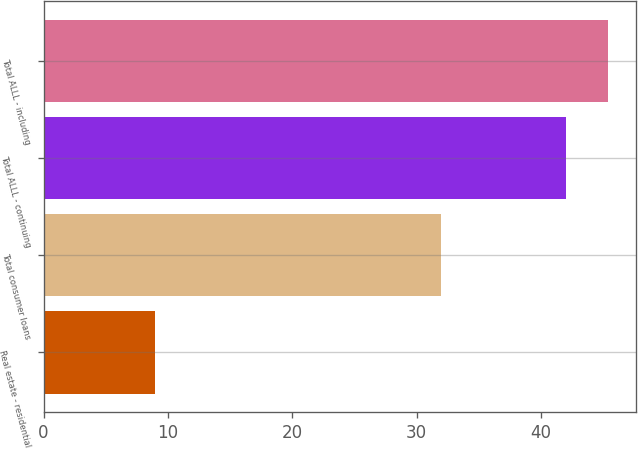<chart> <loc_0><loc_0><loc_500><loc_500><bar_chart><fcel>Real estate - residential<fcel>Total consumer loans<fcel>Total ALLL - continuing<fcel>Total ALLL - including<nl><fcel>9<fcel>32<fcel>42<fcel>45.4<nl></chart> 